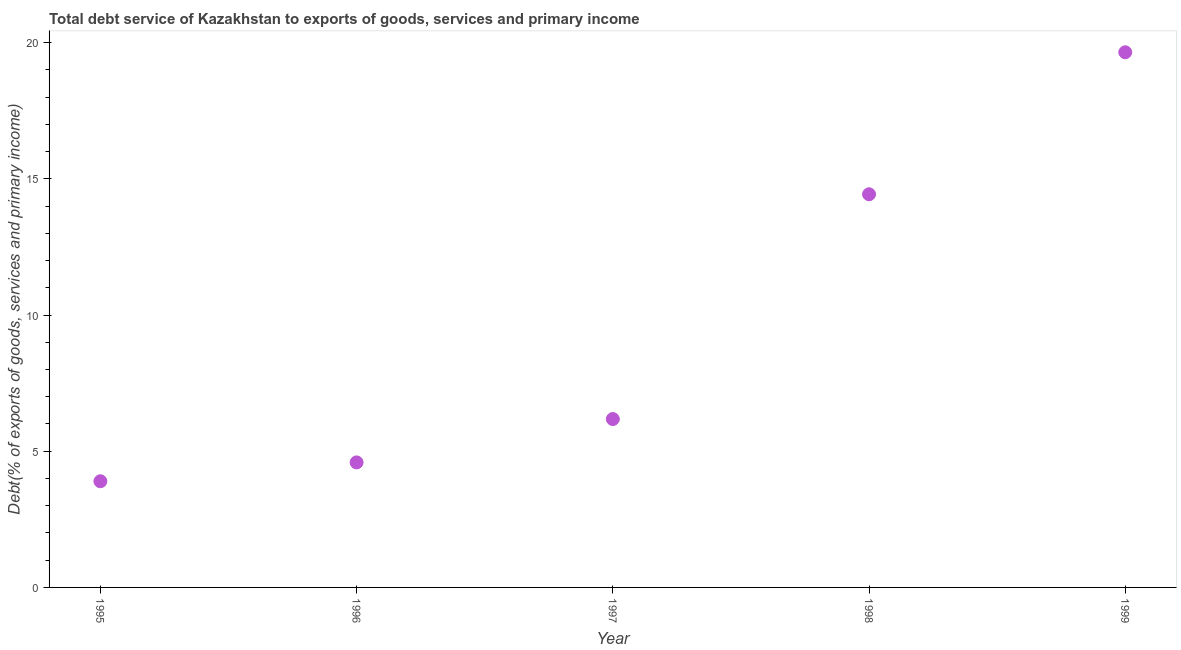What is the total debt service in 1997?
Keep it short and to the point. 6.18. Across all years, what is the maximum total debt service?
Give a very brief answer. 19.64. Across all years, what is the minimum total debt service?
Provide a succinct answer. 3.9. In which year was the total debt service maximum?
Provide a succinct answer. 1999. What is the sum of the total debt service?
Your answer should be compact. 48.74. What is the difference between the total debt service in 1998 and 1999?
Offer a terse response. -5.21. What is the average total debt service per year?
Your response must be concise. 9.75. What is the median total debt service?
Your answer should be compact. 6.18. In how many years, is the total debt service greater than 8 %?
Ensure brevity in your answer.  2. What is the ratio of the total debt service in 1995 to that in 1997?
Give a very brief answer. 0.63. Is the difference between the total debt service in 1998 and 1999 greater than the difference between any two years?
Offer a very short reply. No. What is the difference between the highest and the second highest total debt service?
Offer a terse response. 5.21. Is the sum of the total debt service in 1995 and 1999 greater than the maximum total debt service across all years?
Your answer should be very brief. Yes. What is the difference between the highest and the lowest total debt service?
Offer a terse response. 15.75. In how many years, is the total debt service greater than the average total debt service taken over all years?
Provide a short and direct response. 2. How many years are there in the graph?
Offer a very short reply. 5. What is the difference between two consecutive major ticks on the Y-axis?
Provide a succinct answer. 5. What is the title of the graph?
Your answer should be very brief. Total debt service of Kazakhstan to exports of goods, services and primary income. What is the label or title of the Y-axis?
Provide a succinct answer. Debt(% of exports of goods, services and primary income). What is the Debt(% of exports of goods, services and primary income) in 1995?
Provide a short and direct response. 3.9. What is the Debt(% of exports of goods, services and primary income) in 1996?
Provide a short and direct response. 4.59. What is the Debt(% of exports of goods, services and primary income) in 1997?
Keep it short and to the point. 6.18. What is the Debt(% of exports of goods, services and primary income) in 1998?
Provide a short and direct response. 14.43. What is the Debt(% of exports of goods, services and primary income) in 1999?
Your answer should be compact. 19.64. What is the difference between the Debt(% of exports of goods, services and primary income) in 1995 and 1996?
Provide a succinct answer. -0.69. What is the difference between the Debt(% of exports of goods, services and primary income) in 1995 and 1997?
Provide a succinct answer. -2.28. What is the difference between the Debt(% of exports of goods, services and primary income) in 1995 and 1998?
Make the answer very short. -10.53. What is the difference between the Debt(% of exports of goods, services and primary income) in 1995 and 1999?
Provide a succinct answer. -15.75. What is the difference between the Debt(% of exports of goods, services and primary income) in 1996 and 1997?
Give a very brief answer. -1.59. What is the difference between the Debt(% of exports of goods, services and primary income) in 1996 and 1998?
Offer a very short reply. -9.84. What is the difference between the Debt(% of exports of goods, services and primary income) in 1996 and 1999?
Your response must be concise. -15.05. What is the difference between the Debt(% of exports of goods, services and primary income) in 1997 and 1998?
Your answer should be very brief. -8.25. What is the difference between the Debt(% of exports of goods, services and primary income) in 1997 and 1999?
Provide a short and direct response. -13.46. What is the difference between the Debt(% of exports of goods, services and primary income) in 1998 and 1999?
Your answer should be very brief. -5.21. What is the ratio of the Debt(% of exports of goods, services and primary income) in 1995 to that in 1996?
Ensure brevity in your answer.  0.85. What is the ratio of the Debt(% of exports of goods, services and primary income) in 1995 to that in 1997?
Your answer should be compact. 0.63. What is the ratio of the Debt(% of exports of goods, services and primary income) in 1995 to that in 1998?
Your answer should be very brief. 0.27. What is the ratio of the Debt(% of exports of goods, services and primary income) in 1995 to that in 1999?
Keep it short and to the point. 0.2. What is the ratio of the Debt(% of exports of goods, services and primary income) in 1996 to that in 1997?
Offer a terse response. 0.74. What is the ratio of the Debt(% of exports of goods, services and primary income) in 1996 to that in 1998?
Ensure brevity in your answer.  0.32. What is the ratio of the Debt(% of exports of goods, services and primary income) in 1996 to that in 1999?
Make the answer very short. 0.23. What is the ratio of the Debt(% of exports of goods, services and primary income) in 1997 to that in 1998?
Offer a terse response. 0.43. What is the ratio of the Debt(% of exports of goods, services and primary income) in 1997 to that in 1999?
Your response must be concise. 0.32. What is the ratio of the Debt(% of exports of goods, services and primary income) in 1998 to that in 1999?
Provide a succinct answer. 0.73. 